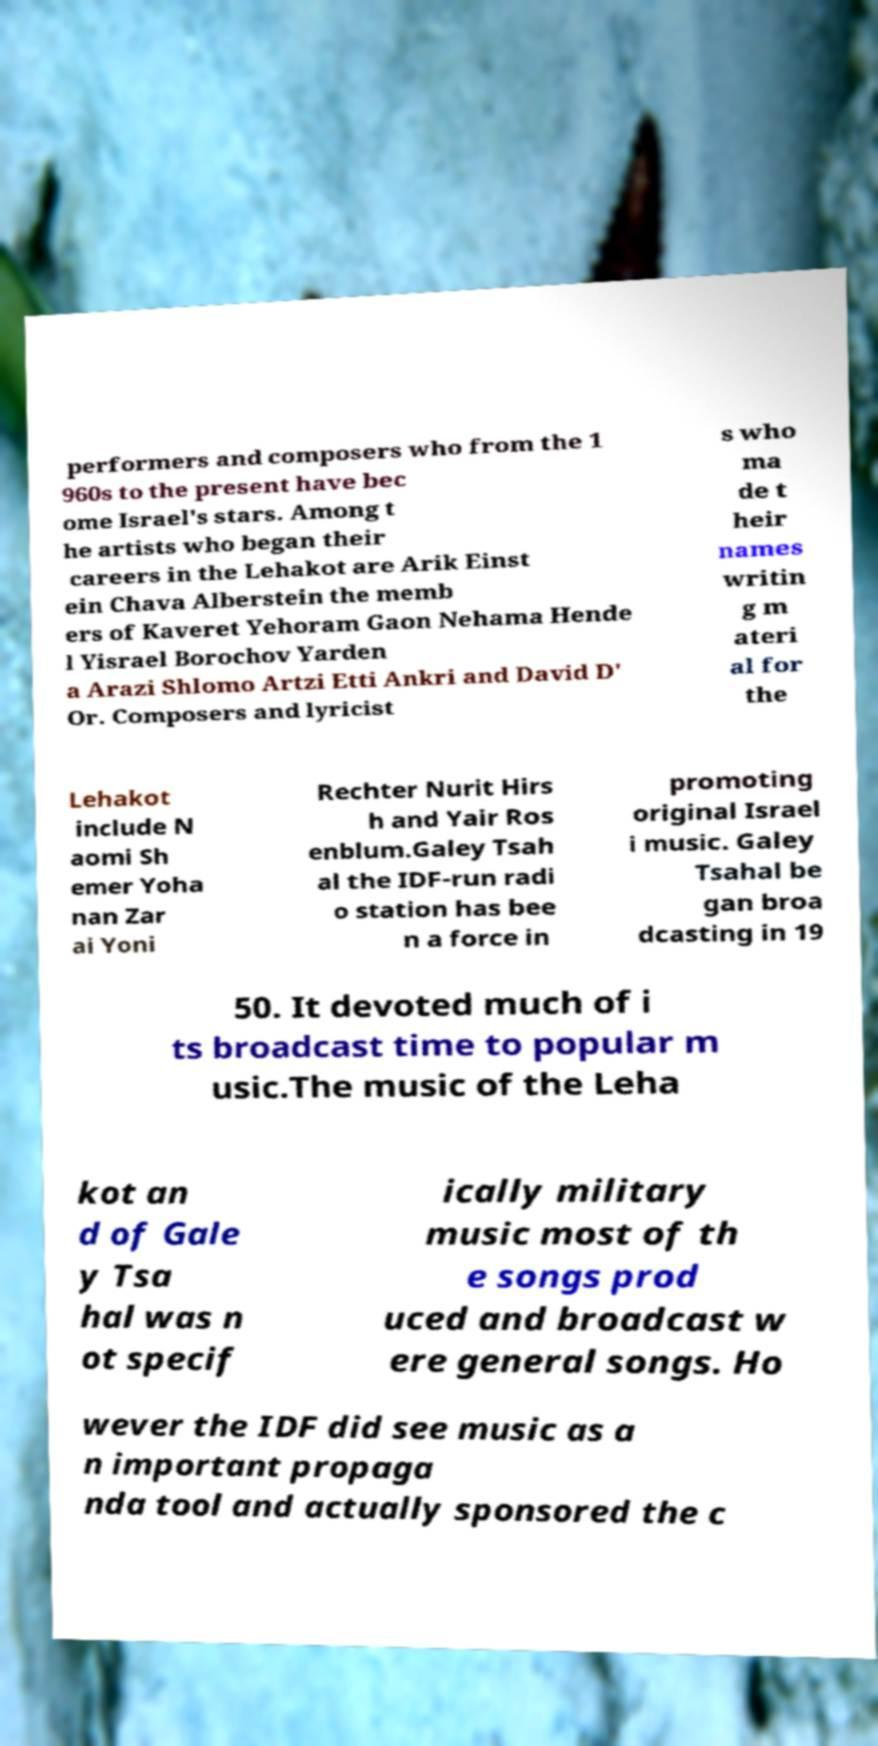For documentation purposes, I need the text within this image transcribed. Could you provide that? performers and composers who from the 1 960s to the present have bec ome Israel's stars. Among t he artists who began their careers in the Lehakot are Arik Einst ein Chava Alberstein the memb ers of Kaveret Yehoram Gaon Nehama Hende l Yisrael Borochov Yarden a Arazi Shlomo Artzi Etti Ankri and David D' Or. Composers and lyricist s who ma de t heir names writin g m ateri al for the Lehakot include N aomi Sh emer Yoha nan Zar ai Yoni Rechter Nurit Hirs h and Yair Ros enblum.Galey Tsah al the IDF-run radi o station has bee n a force in promoting original Israel i music. Galey Tsahal be gan broa dcasting in 19 50. It devoted much of i ts broadcast time to popular m usic.The music of the Leha kot an d of Gale y Tsa hal was n ot specif ically military music most of th e songs prod uced and broadcast w ere general songs. Ho wever the IDF did see music as a n important propaga nda tool and actually sponsored the c 